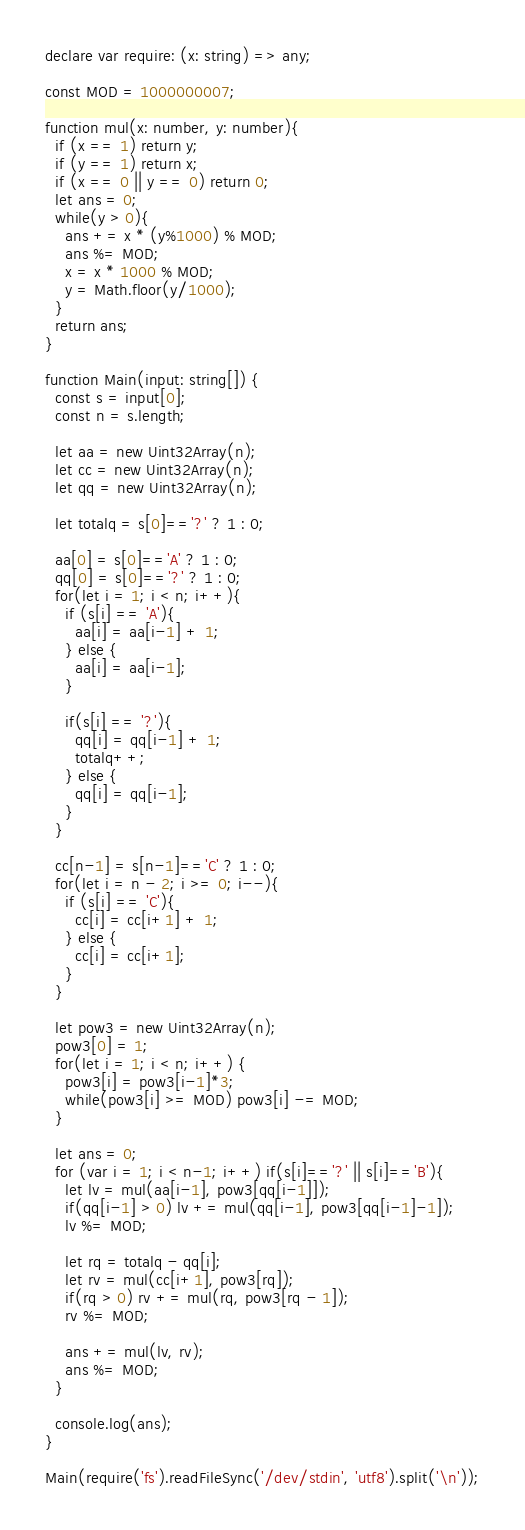Convert code to text. <code><loc_0><loc_0><loc_500><loc_500><_TypeScript_>declare var require: (x: string) => any;

const MOD = 1000000007;

function mul(x: number, y: number){
  if (x == 1) return y;
  if (y == 1) return x;
  if (x == 0 || y == 0) return 0;
  let ans = 0;
  while(y > 0){
    ans += x * (y%1000) % MOD;
    ans %= MOD;
    x = x * 1000 % MOD;
    y = Math.floor(y/1000);
  }
  return ans;
}

function Main(input: string[]) {
  const s = input[0];
  const n = s.length;

  let aa = new Uint32Array(n);
  let cc = new Uint32Array(n);
  let qq = new Uint32Array(n);

  let totalq = s[0]=='?' ? 1 : 0;

  aa[0] = s[0]=='A' ? 1 : 0;
  qq[0] = s[0]=='?' ? 1 : 0;
  for(let i = 1; i < n; i++){
    if (s[i] == 'A'){
      aa[i] = aa[i-1] + 1;
    } else {
      aa[i] = aa[i-1];
    }

    if(s[i] == '?'){
      qq[i] = qq[i-1] + 1;
      totalq++;
    } else {
      qq[i] = qq[i-1];
    }
  }

  cc[n-1] = s[n-1]=='C' ? 1 : 0;
  for(let i = n - 2; i >= 0; i--){
    if (s[i] == 'C'){
      cc[i] = cc[i+1] + 1;
    } else {
      cc[i] = cc[i+1];
    }
  }

  let pow3 = new Uint32Array(n);
  pow3[0] = 1;
  for(let i = 1; i < n; i++) {
    pow3[i] = pow3[i-1]*3;
    while(pow3[i] >= MOD) pow3[i] -= MOD;
  }

  let ans = 0;
  for (var i = 1; i < n-1; i++) if(s[i]=='?' || s[i]=='B'){
    let lv = mul(aa[i-1], pow3[qq[i-1]]);
    if(qq[i-1] > 0) lv += mul(qq[i-1], pow3[qq[i-1]-1]);
    lv %= MOD;

    let rq = totalq - qq[i];
    let rv = mul(cc[i+1], pow3[rq]);
    if(rq > 0) rv += mul(rq, pow3[rq - 1]);
    rv %= MOD;

    ans += mul(lv, rv);
    ans %= MOD;
  }

  console.log(ans);
}

Main(require('fs').readFileSync('/dev/stdin', 'utf8').split('\n'));
</code> 